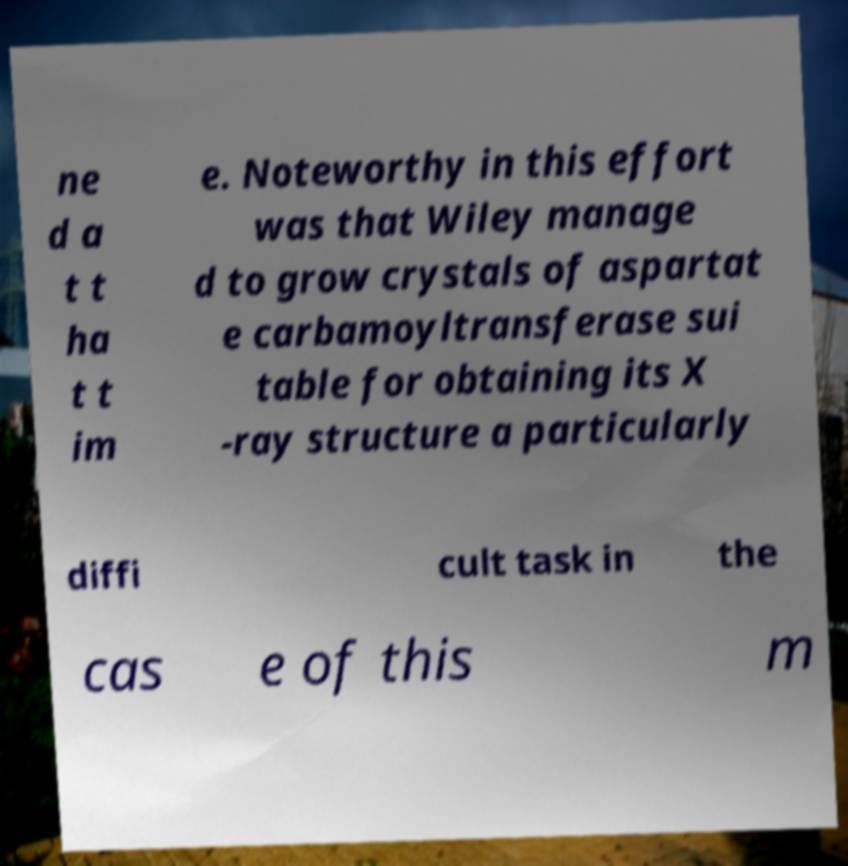Please identify and transcribe the text found in this image. ne d a t t ha t t im e. Noteworthy in this effort was that Wiley manage d to grow crystals of aspartat e carbamoyltransferase sui table for obtaining its X -ray structure a particularly diffi cult task in the cas e of this m 